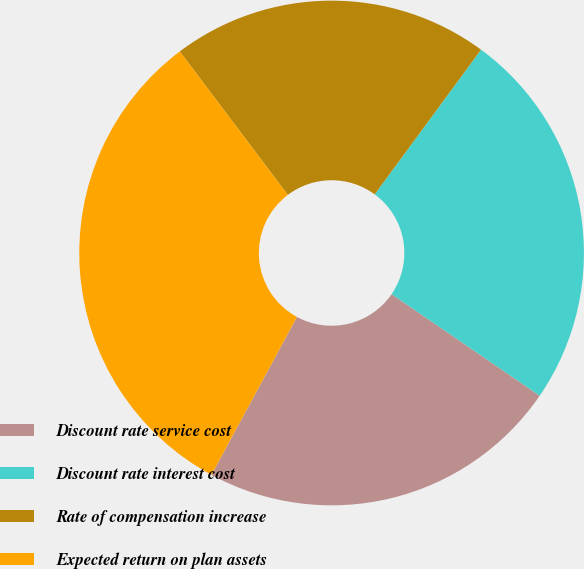Convert chart to OTSL. <chart><loc_0><loc_0><loc_500><loc_500><pie_chart><fcel>Discount rate service cost<fcel>Discount rate interest cost<fcel>Rate of compensation increase<fcel>Expected return on plan assets<nl><fcel>23.33%<fcel>24.48%<fcel>20.36%<fcel>31.82%<nl></chart> 